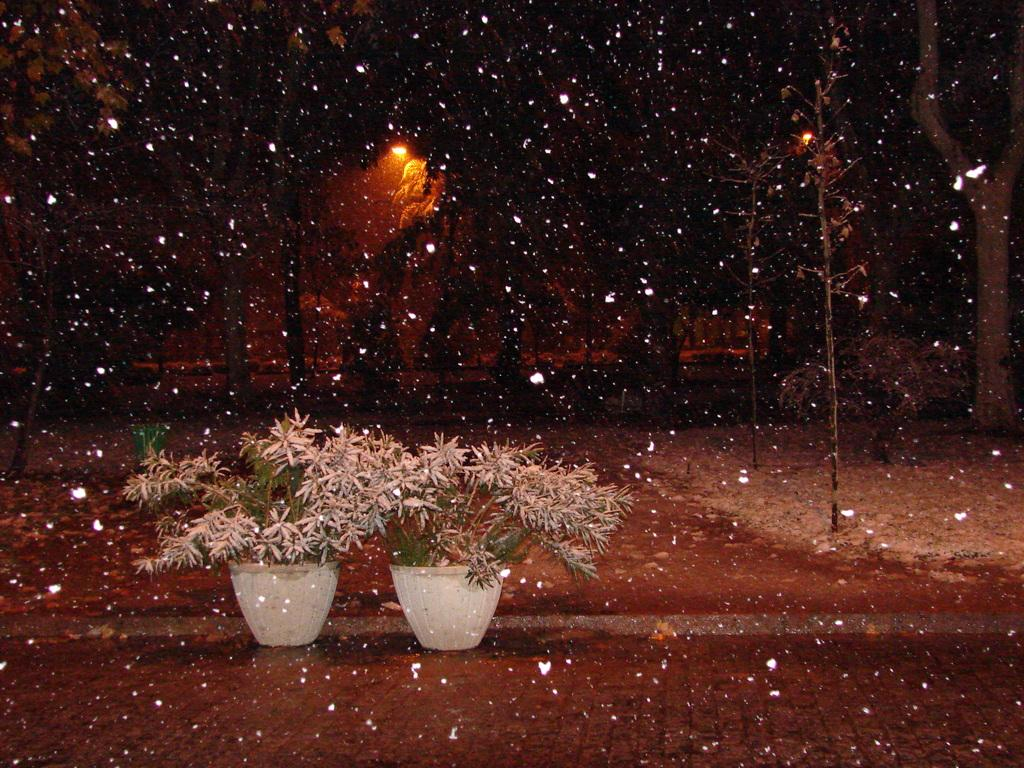What can be seen at the bottom of the picture? There are two plants in flower pots at the bottom of the picture. What is happening in the image? It is snowing in the image. What can be seen in the background of the image? There are trees, poles, and snow visible in the background of the image. What type of lighting is present in the background of the image? There is a street light in the background of the image. What statement can be made about the room in the image? There is no room present in the image; it is an outdoor scene with snow and trees. What type of polish is visible on the trees in the image? There is no polish visible on the trees in the image; they are covered in snow. 